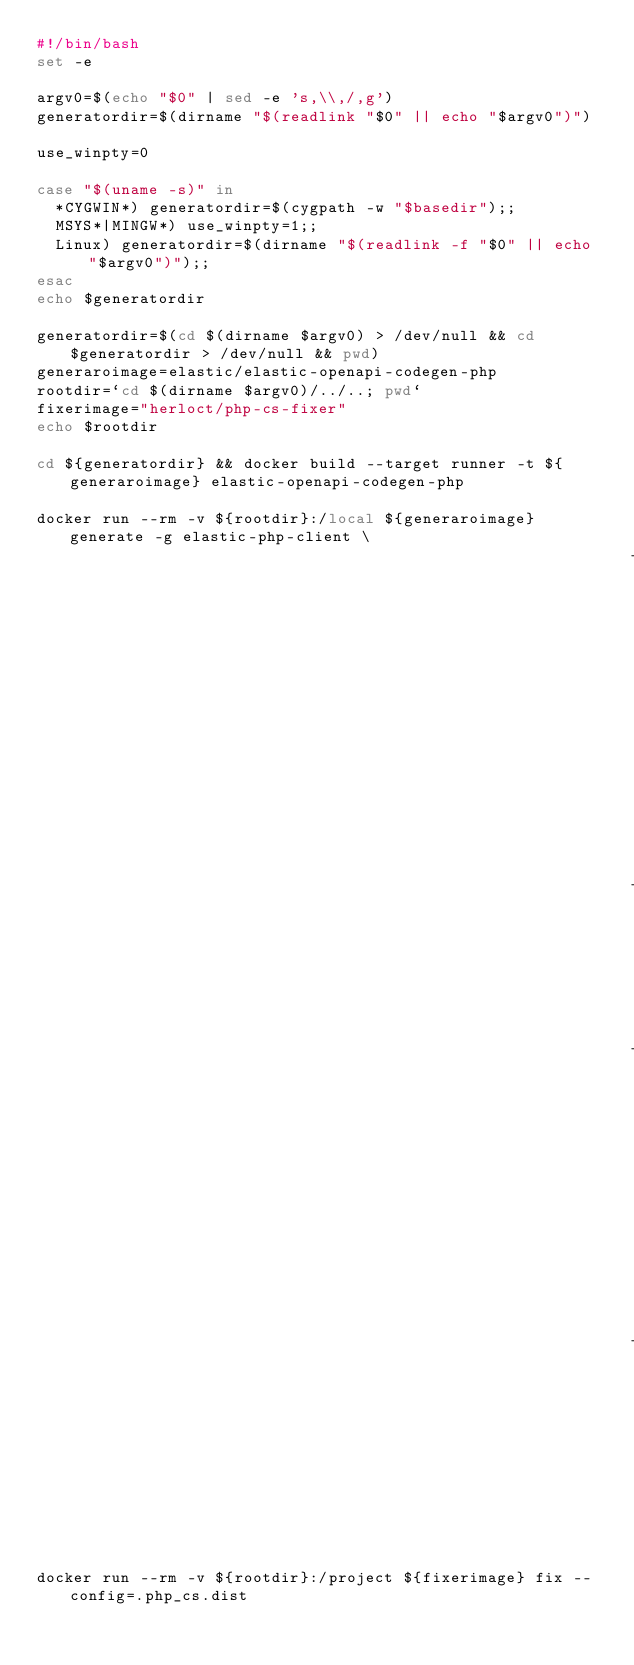Convert code to text. <code><loc_0><loc_0><loc_500><loc_500><_Bash_>#!/bin/bash
set -e

argv0=$(echo "$0" | sed -e 's,\\,/,g')
generatordir=$(dirname "$(readlink "$0" || echo "$argv0")")

use_winpty=0

case "$(uname -s)" in
  *CYGWIN*) generatordir=$(cygpath -w "$basedir");;
  MSYS*|MINGW*) use_winpty=1;;
  Linux) generatordir=$(dirname "$(readlink -f "$0" || echo "$argv0")");;
esac
echo $generatordir

generatordir=$(cd $(dirname $argv0) > /dev/null && cd $generatordir > /dev/null && pwd)
generaroimage=elastic/elastic-openapi-codegen-php
rootdir=`cd $(dirname $argv0)/../..; pwd`
fixerimage="herloct/php-cs-fixer"
echo $rootdir

cd ${generatordir} && docker build --target runner -t ${generaroimage} elastic-openapi-codegen-php

docker run --rm -v ${rootdir}:/local ${generaroimage} generate -g elastic-php-client \
                                                               -i /local/resources/api/api-spec.yml \
                                                               -o /local/ \
                                                               -c /local/resources/api/config.json \
                                                               -t /local/resources/api/templates

docker run --rm -v ${rootdir}:/project ${fixerimage} fix --config=.php_cs.dist
</code> 